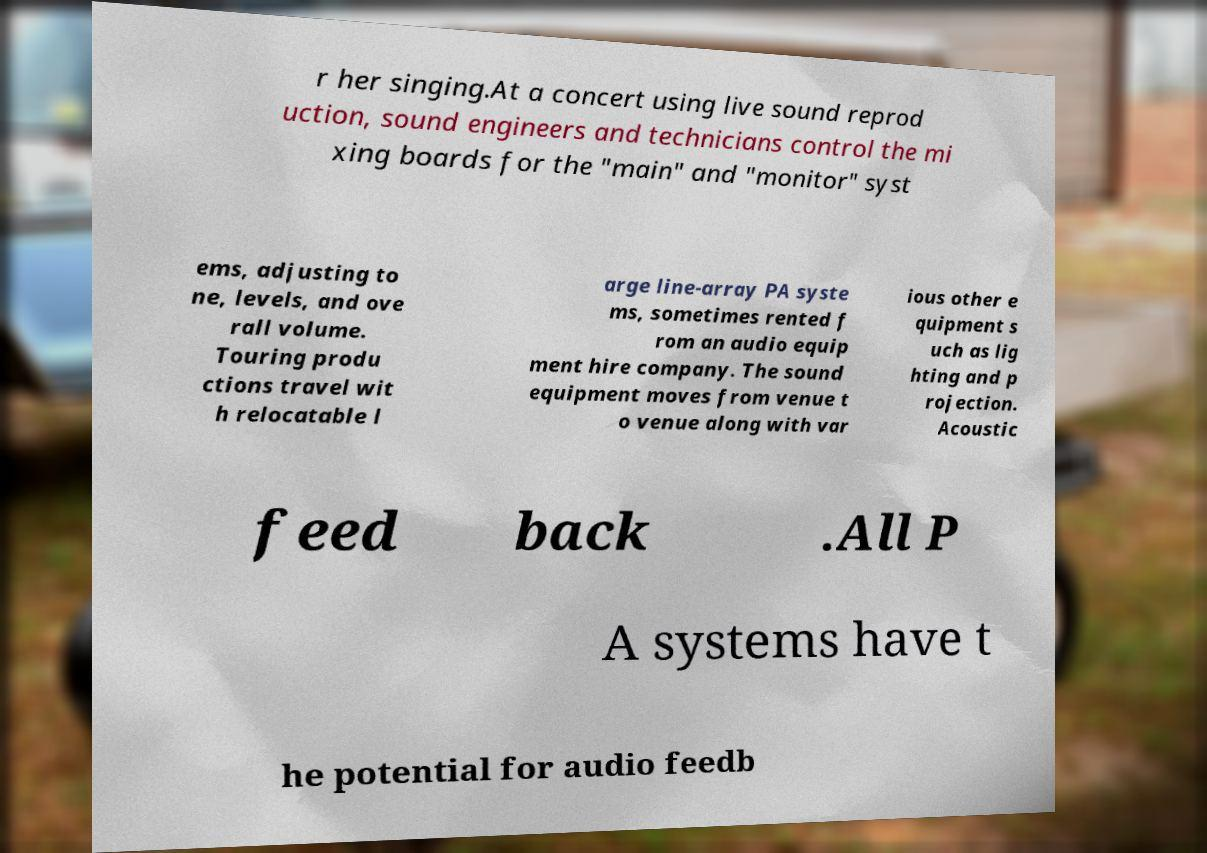There's text embedded in this image that I need extracted. Can you transcribe it verbatim? r her singing.At a concert using live sound reprod uction, sound engineers and technicians control the mi xing boards for the "main" and "monitor" syst ems, adjusting to ne, levels, and ove rall volume. Touring produ ctions travel wit h relocatable l arge line-array PA syste ms, sometimes rented f rom an audio equip ment hire company. The sound equipment moves from venue t o venue along with var ious other e quipment s uch as lig hting and p rojection. Acoustic feed back .All P A systems have t he potential for audio feedb 